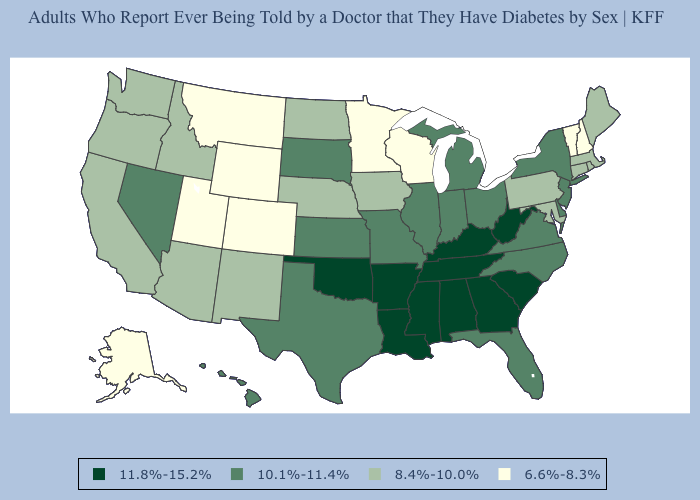What is the lowest value in the USA?
Write a very short answer. 6.6%-8.3%. Name the states that have a value in the range 8.4%-10.0%?
Be succinct. Arizona, California, Connecticut, Idaho, Iowa, Maine, Maryland, Massachusetts, Nebraska, New Mexico, North Dakota, Oregon, Pennsylvania, Rhode Island, Washington. Is the legend a continuous bar?
Keep it brief. No. What is the value of Indiana?
Be succinct. 10.1%-11.4%. Name the states that have a value in the range 11.8%-15.2%?
Answer briefly. Alabama, Arkansas, Georgia, Kentucky, Louisiana, Mississippi, Oklahoma, South Carolina, Tennessee, West Virginia. Does Massachusetts have a lower value than Delaware?
Answer briefly. Yes. What is the value of Ohio?
Quick response, please. 10.1%-11.4%. Name the states that have a value in the range 10.1%-11.4%?
Be succinct. Delaware, Florida, Hawaii, Illinois, Indiana, Kansas, Michigan, Missouri, Nevada, New Jersey, New York, North Carolina, Ohio, South Dakota, Texas, Virginia. Which states have the lowest value in the USA?
Quick response, please. Alaska, Colorado, Minnesota, Montana, New Hampshire, Utah, Vermont, Wisconsin, Wyoming. What is the lowest value in the USA?
Short answer required. 6.6%-8.3%. What is the value of Louisiana?
Keep it brief. 11.8%-15.2%. Name the states that have a value in the range 8.4%-10.0%?
Answer briefly. Arizona, California, Connecticut, Idaho, Iowa, Maine, Maryland, Massachusetts, Nebraska, New Mexico, North Dakota, Oregon, Pennsylvania, Rhode Island, Washington. What is the lowest value in the MidWest?
Be succinct. 6.6%-8.3%. Does Washington have the lowest value in the USA?
Answer briefly. No. What is the value of New Jersey?
Concise answer only. 10.1%-11.4%. 